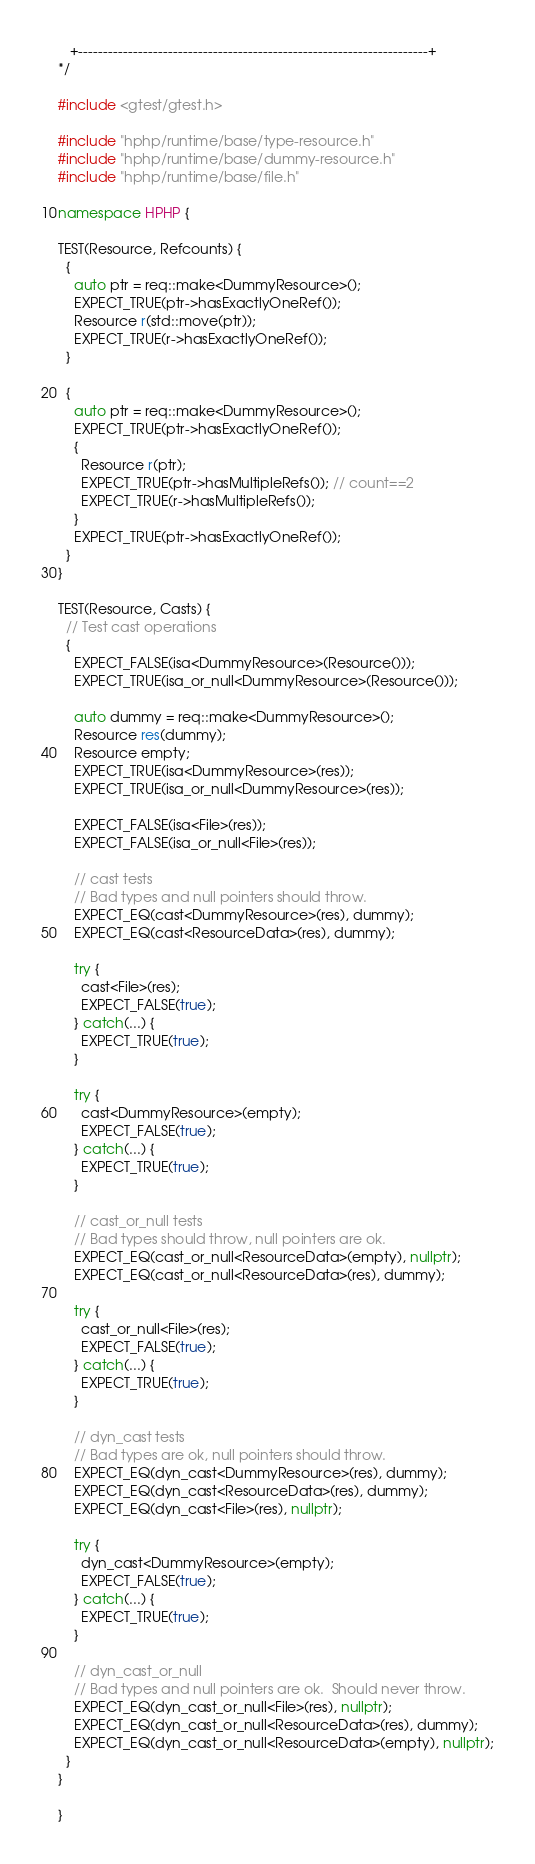<code> <loc_0><loc_0><loc_500><loc_500><_C++_>   +----------------------------------------------------------------------+
*/

#include <gtest/gtest.h>

#include "hphp/runtime/base/type-resource.h"
#include "hphp/runtime/base/dummy-resource.h"
#include "hphp/runtime/base/file.h"

namespace HPHP {

TEST(Resource, Refcounts) {
  {
    auto ptr = req::make<DummyResource>();
    EXPECT_TRUE(ptr->hasExactlyOneRef());
    Resource r(std::move(ptr));
    EXPECT_TRUE(r->hasExactlyOneRef());
  }

  {
    auto ptr = req::make<DummyResource>();
    EXPECT_TRUE(ptr->hasExactlyOneRef());
    {
      Resource r(ptr);
      EXPECT_TRUE(ptr->hasMultipleRefs()); // count==2
      EXPECT_TRUE(r->hasMultipleRefs());
    }
    EXPECT_TRUE(ptr->hasExactlyOneRef());
  }
}

TEST(Resource, Casts) {
  // Test cast operations
  {
    EXPECT_FALSE(isa<DummyResource>(Resource()));
    EXPECT_TRUE(isa_or_null<DummyResource>(Resource()));

    auto dummy = req::make<DummyResource>();
    Resource res(dummy);
    Resource empty;
    EXPECT_TRUE(isa<DummyResource>(res));
    EXPECT_TRUE(isa_or_null<DummyResource>(res));

    EXPECT_FALSE(isa<File>(res));
    EXPECT_FALSE(isa_or_null<File>(res));

    // cast tests
    // Bad types and null pointers should throw.
    EXPECT_EQ(cast<DummyResource>(res), dummy);
    EXPECT_EQ(cast<ResourceData>(res), dummy);

    try {
      cast<File>(res);
      EXPECT_FALSE(true);
    } catch(...) {
      EXPECT_TRUE(true);
    }

    try {
      cast<DummyResource>(empty);
      EXPECT_FALSE(true);
    } catch(...) {
      EXPECT_TRUE(true);
    }

    // cast_or_null tests
    // Bad types should throw, null pointers are ok.
    EXPECT_EQ(cast_or_null<ResourceData>(empty), nullptr);
    EXPECT_EQ(cast_or_null<ResourceData>(res), dummy);

    try {
      cast_or_null<File>(res);
      EXPECT_FALSE(true);
    } catch(...) {
      EXPECT_TRUE(true);
    }

    // dyn_cast tests
    // Bad types are ok, null pointers should throw.
    EXPECT_EQ(dyn_cast<DummyResource>(res), dummy);
    EXPECT_EQ(dyn_cast<ResourceData>(res), dummy);
    EXPECT_EQ(dyn_cast<File>(res), nullptr);

    try {
      dyn_cast<DummyResource>(empty);
      EXPECT_FALSE(true);
    } catch(...) {
      EXPECT_TRUE(true);
    }

    // dyn_cast_or_null
    // Bad types and null pointers are ok.  Should never throw.
    EXPECT_EQ(dyn_cast_or_null<File>(res), nullptr);
    EXPECT_EQ(dyn_cast_or_null<ResourceData>(res), dummy);
    EXPECT_EQ(dyn_cast_or_null<ResourceData>(empty), nullptr);
  }
}

}
</code> 